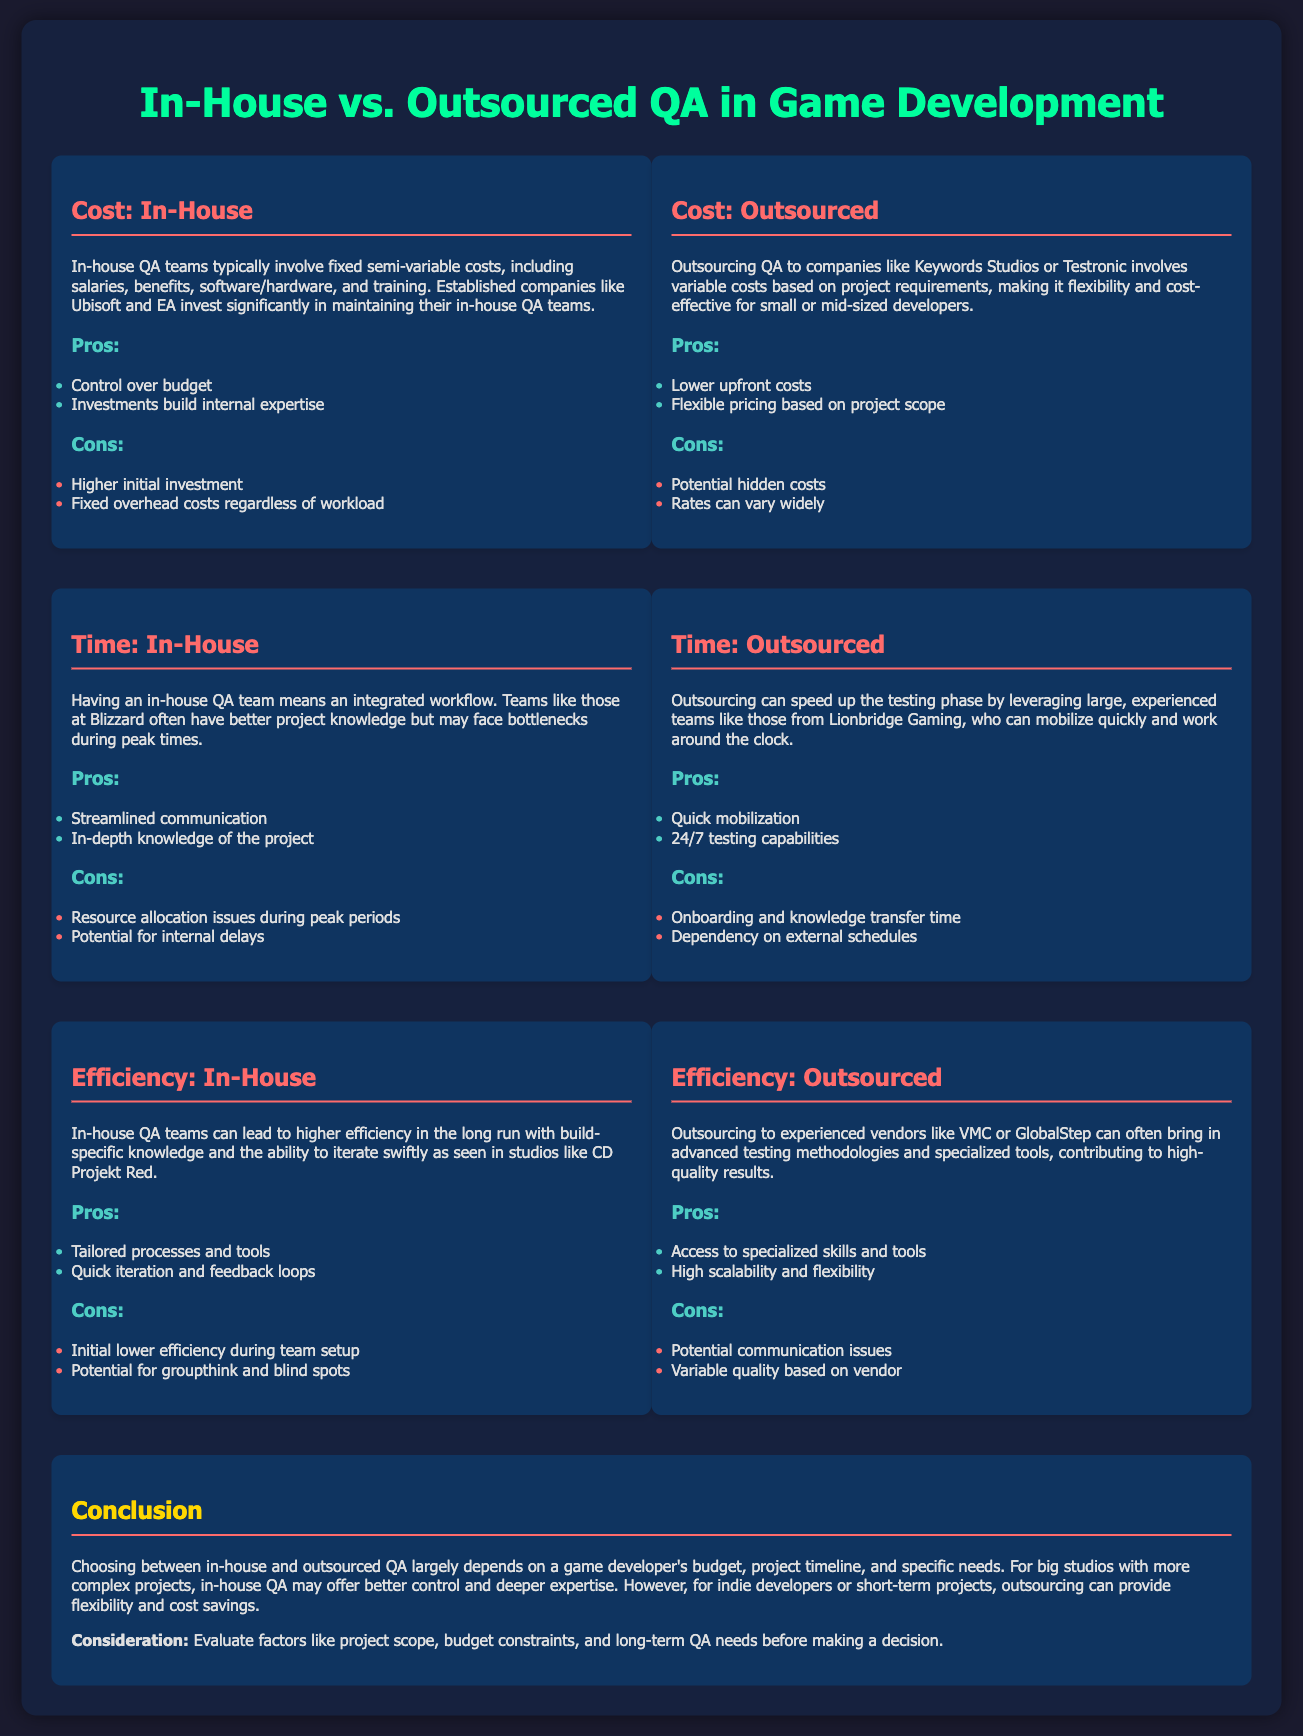What are the fixed costs associated with in-house QA? Fixed costs include salaries, benefits, software/hardware, and training for in-house teams.
Answer: Salaries, benefits, software/hardware, and training What is a pro of outsourcing QA? One advantage is that outsourcing can provide lower upfront costs for game developers.
Answer: Lower upfront costs What issue might arise from in-house QA during peak periods? In-house teams may experience resource allocation issues during peak periods.
Answer: Resource allocation issues Who are some companies associated with outsourced QA? Companies like Keywords Studios and Testronic are commonly associated with outsourced QA.
Answer: Keywords Studios and Testronic What is a significant con of outsourcing QA? A major drawback is that there can be potential hidden costs associated with outsourcing.
Answer: Potential hidden costs In which scenario might in-house QA be more beneficial? In-house QA is often better for big studios with complex projects needing deeper expertise.
Answer: Big studios with complex projects What is a notable efficiency benefit of in-house QA? In-house QA teams may provide quick iteration and feedback loops due to their tailored processes.
Answer: Quick iteration and feedback loops What can potentially vary with outsourced QA services? The quality of services can vary based on the vendor chosen for outsourcing.
Answer: Variable quality based on vendor What type of flexibility does outsourcing provide? Outsourcing offers flexible pricing based on project scope, making it adaptable for smaller developers.
Answer: Flexible pricing based on project scope 